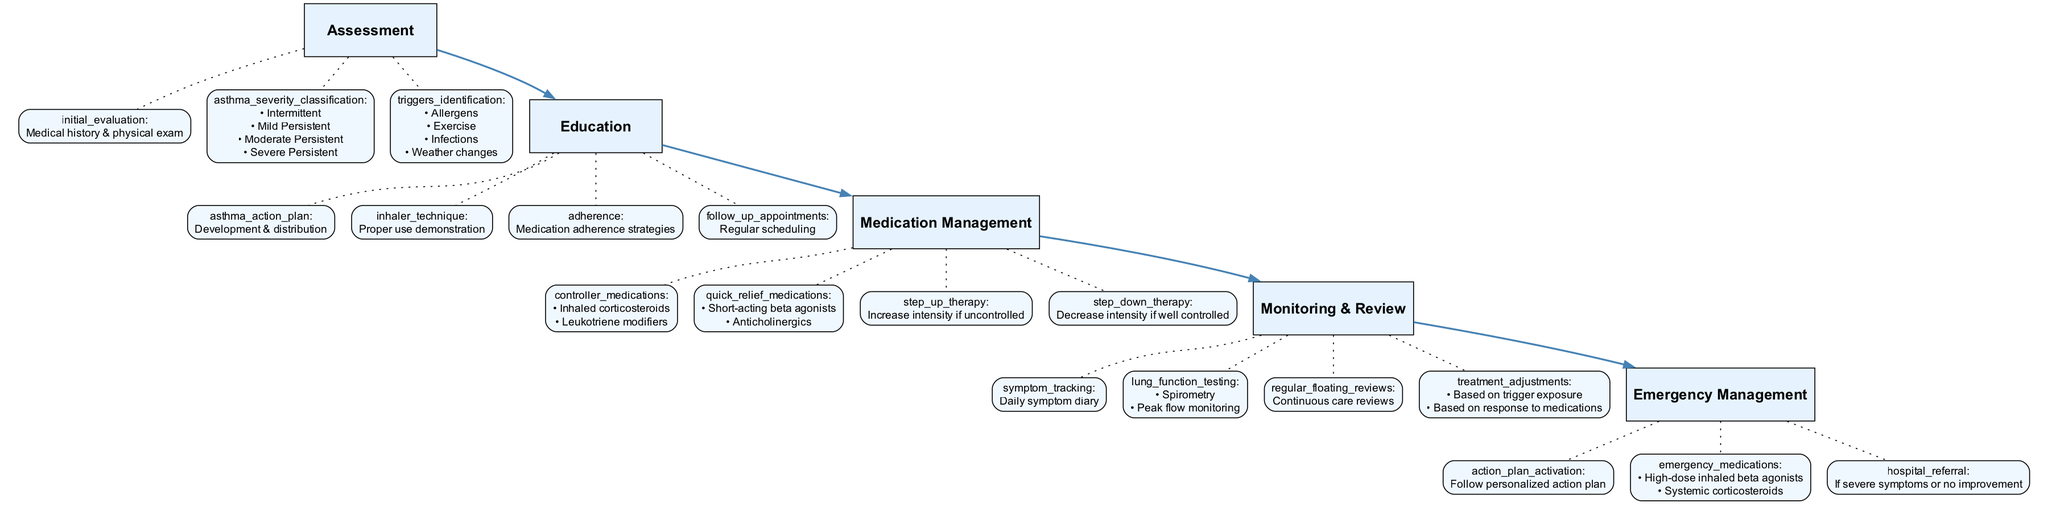What is the first step in the Pediatric Asthma Management Steps? The diagram lists the first step in the flow as "Assessment". This can be identified at the top of the diagram structure, where the first node indicates the overall sequence of the management steps.
Answer: Assessment How many main steps are there in the clinical pathway? By counting the distinct nodes labeled for each step in the diagram, there are a total of five main steps outlined in the Pediatric Asthma Management Steps.
Answer: 5 What are the elements involved in the "Emergency Management" step? The diagram indicates the elements for "Emergency Management" are "action plan activation", "emergency medications", and "hospital referral". By analyzing the associated elements connected to the "Emergency Management" node, we derive this answer.
Answer: action plan activation, emergency medications, hospital referral In which step would you find the "Daily symptom diary"? The "Daily symptom diary" is listed as part of the elements for the "Monitoring & Review" step. Looking through the nodes, one can identify where this element is connected and see under which step it resides.
Answer: Monitoring & Review What type of medications are included in "Quick Relief Medications"? The medications categorized under "Quick Relief Medications" in the diagram are "Short-acting beta agonists" and "Anticholinergics". These can be identified under the "Medication Management" step connected to its respective node.
Answer: Short-acting beta agonists, Anticholinergics What actions are taken if asthma is uncontrolled according to the pathway? According to the diagram, if asthma is uncontrolled, the action taken is "Increase intensity if uncontrolled". This statement can be deduced from the corresponding node in the "Medication Management" step where "step up therapy" is detailed.
Answer: Increase intensity if uncontrolled What factors are considered for "Treatment adjustments"? The diagram lists "Based on trigger exposure" and "Based on response to medications" as factors for treatment adjustments. They are found under the "Monitoring & Review" step, connecting these elements with how adjustments should be made.
Answer: Based on trigger exposure, Based on response to medications What is the purpose of the "Asthma Action Plan" in the pathway? The "Asthma Action Plan" serves the purpose of "Development & distribution" based on elements listed under the "Education" step. This ties into the diagram where the role of the plan is explicitly connected to educational efforts.
Answer: Development & distribution 